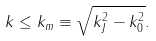Convert formula to latex. <formula><loc_0><loc_0><loc_500><loc_500>k \leq k _ { m } \equiv \sqrt { k _ { J } ^ { 2 } - k _ { 0 } ^ { 2 } } .</formula> 